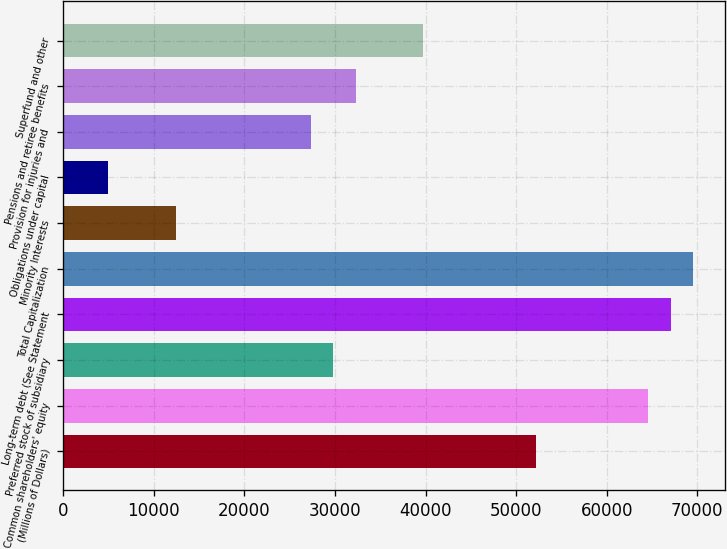Convert chart. <chart><loc_0><loc_0><loc_500><loc_500><bar_chart><fcel>(Millions of Dollars)<fcel>Common shareholders' equity<fcel>Preferred stock of subsidiary<fcel>Long-term debt (See Statement<fcel>Total Capitalization<fcel>Minority Interests<fcel>Obligations under capital<fcel>Provision for injuries and<fcel>Pensions and retiree benefits<fcel>Superfund and other<nl><fcel>52156.6<fcel>64569.6<fcel>29813.2<fcel>67052.2<fcel>69534.8<fcel>12435<fcel>4987.2<fcel>27330.6<fcel>32295.8<fcel>39743.6<nl></chart> 